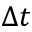<formula> <loc_0><loc_0><loc_500><loc_500>\Delta t</formula> 